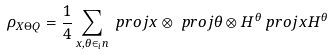Convert formula to latex. <formula><loc_0><loc_0><loc_500><loc_500>\rho _ { X \Theta Q } & = \frac { 1 } { 4 } \sum _ { x , \theta \in _ { i } n } \ p r o j { x } \otimes \ p r o j { \theta } \otimes H ^ { \theta } \ p r o j { x } H ^ { \theta }</formula> 